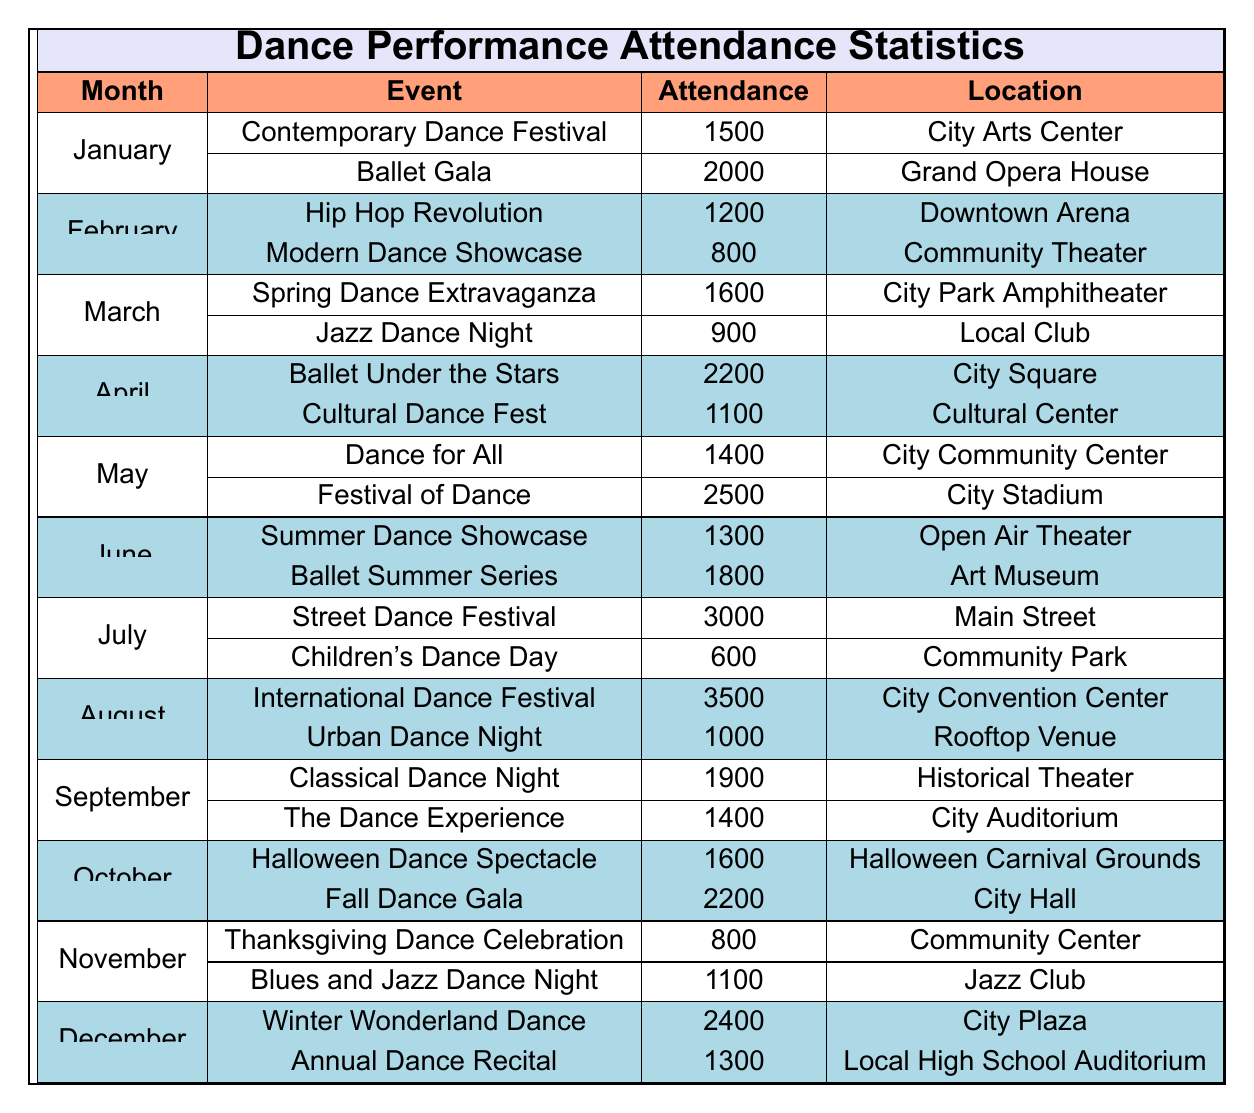What was the highest attendance for a dance performance in July? The table shows that in July, the "Street Dance Festival" had an attendance of 3000, which is higher than "Children’s Dance Day" at 600. Thus, the highest attendance in July is 3000.
Answer: 3000 Which event in August had an attendance of 1000? According to the table, in August, "Urban Dance Night" had an attendance of exactly 1000. The first event, "International Dance Festival," had a higher attendance of 3500.
Answer: Urban Dance Night What is the total attendance for dance performances in October? For October, the attendances are as follows: "Halloween Dance Spectacle" has 1600 and "Fall Dance Gala" has 2200. Adding these together gives us: 1600 + 2200 = 3800.
Answer: 3800 Was the attendance for the "Thanksgiving Dance Celebration" in November more than 1000? The table indicates that the "Thanksgiving Dance Celebration" had an attendance of 800. Since 800 is less than 1000, the answer is no.
Answer: No What is the average attendance for dance performances in the month with the lowest total attendance? Analyzing the table, November has the lowest total attendance: 800 for "Thanksgiving Dance Celebration" and 1100 for "Blues and Jazz Dance Night," totalling 1900. To find the average: 1900 divided by 2 (number of events) equals 950.
Answer: 950 What location hosted the "Festival of Dance"? The table specifies that the "Festival of Dance" took place at the "City Stadium."
Answer: City Stadium Which month had the highest attendance for any dance performance, and what was that attendance? Looking through the table, August had the highest attendance with the "International Dance Festival" at 3500. Therefore, August is the month with the highest attendance.
Answer: August, 3500 Was there more total attendance in December than in July? In December, the attendances are 2400 for "Winter Wonderland Dance" and 1300 for "Annual Dance Recital," totalling 3700. In July, the total attendance is 3000. Since 3700 is greater than 3000, the answer is yes.
Answer: Yes 